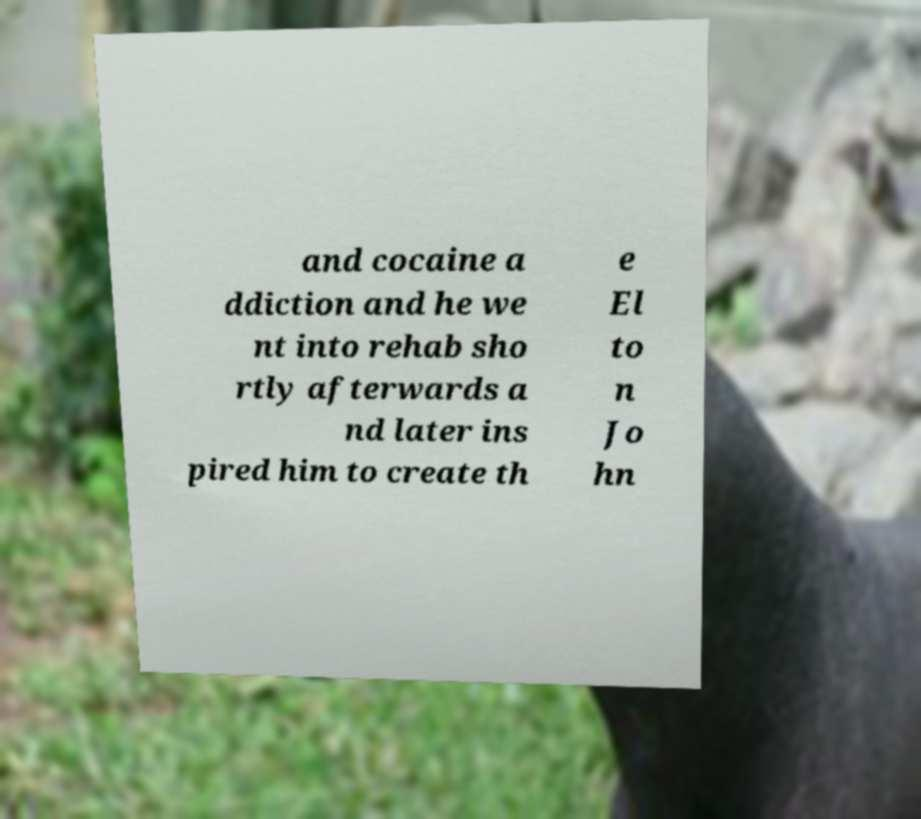For documentation purposes, I need the text within this image transcribed. Could you provide that? and cocaine a ddiction and he we nt into rehab sho rtly afterwards a nd later ins pired him to create th e El to n Jo hn 